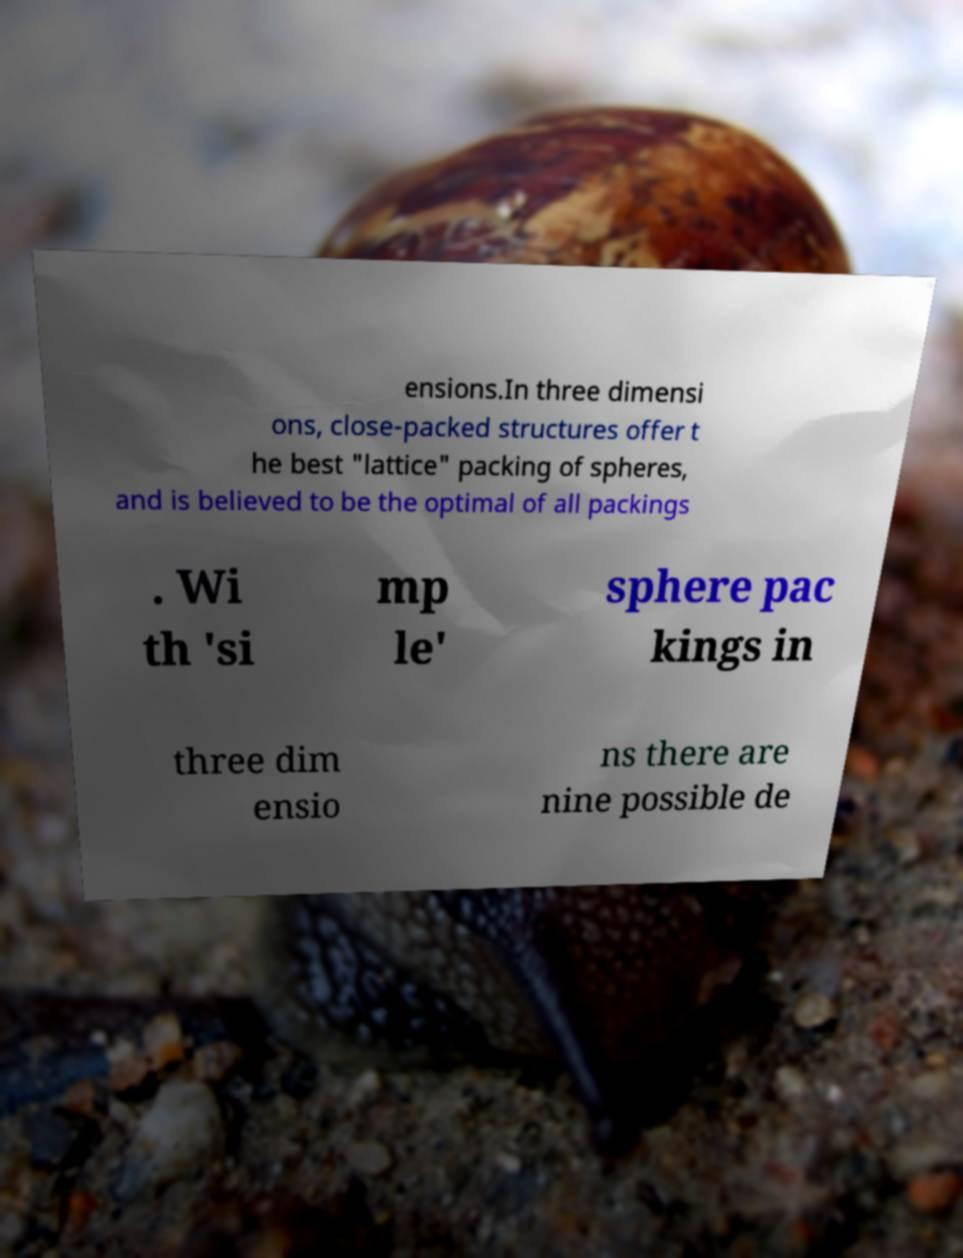Could you extract and type out the text from this image? ensions.In three dimensi ons, close-packed structures offer t he best "lattice" packing of spheres, and is believed to be the optimal of all packings . Wi th 'si mp le' sphere pac kings in three dim ensio ns there are nine possible de 